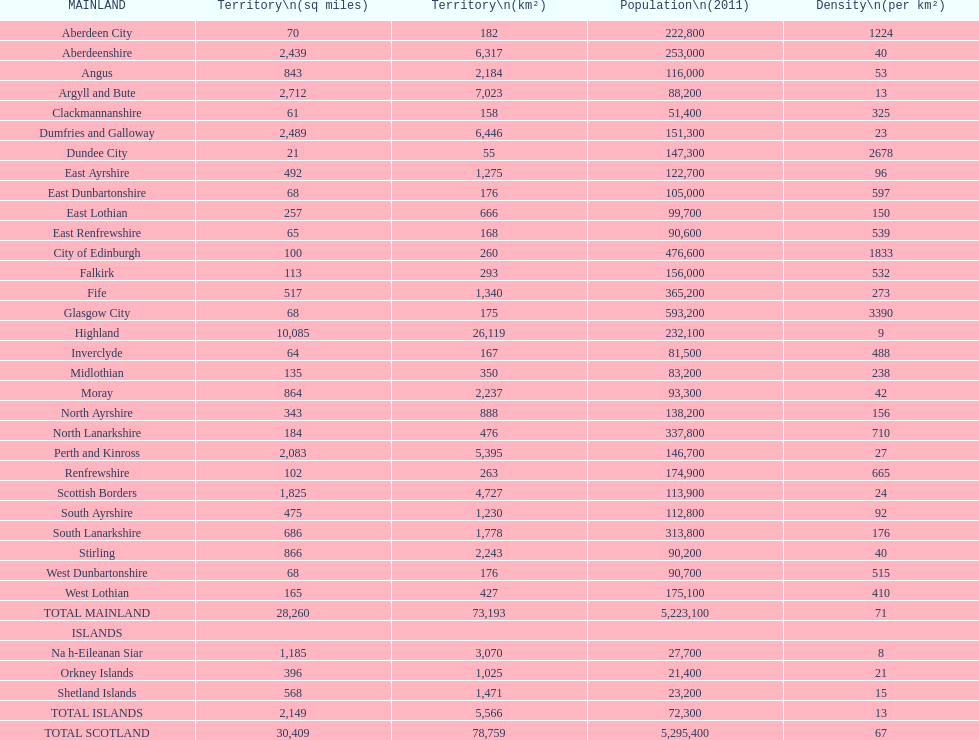What is the usual population density in mainland municipalities? 71. 